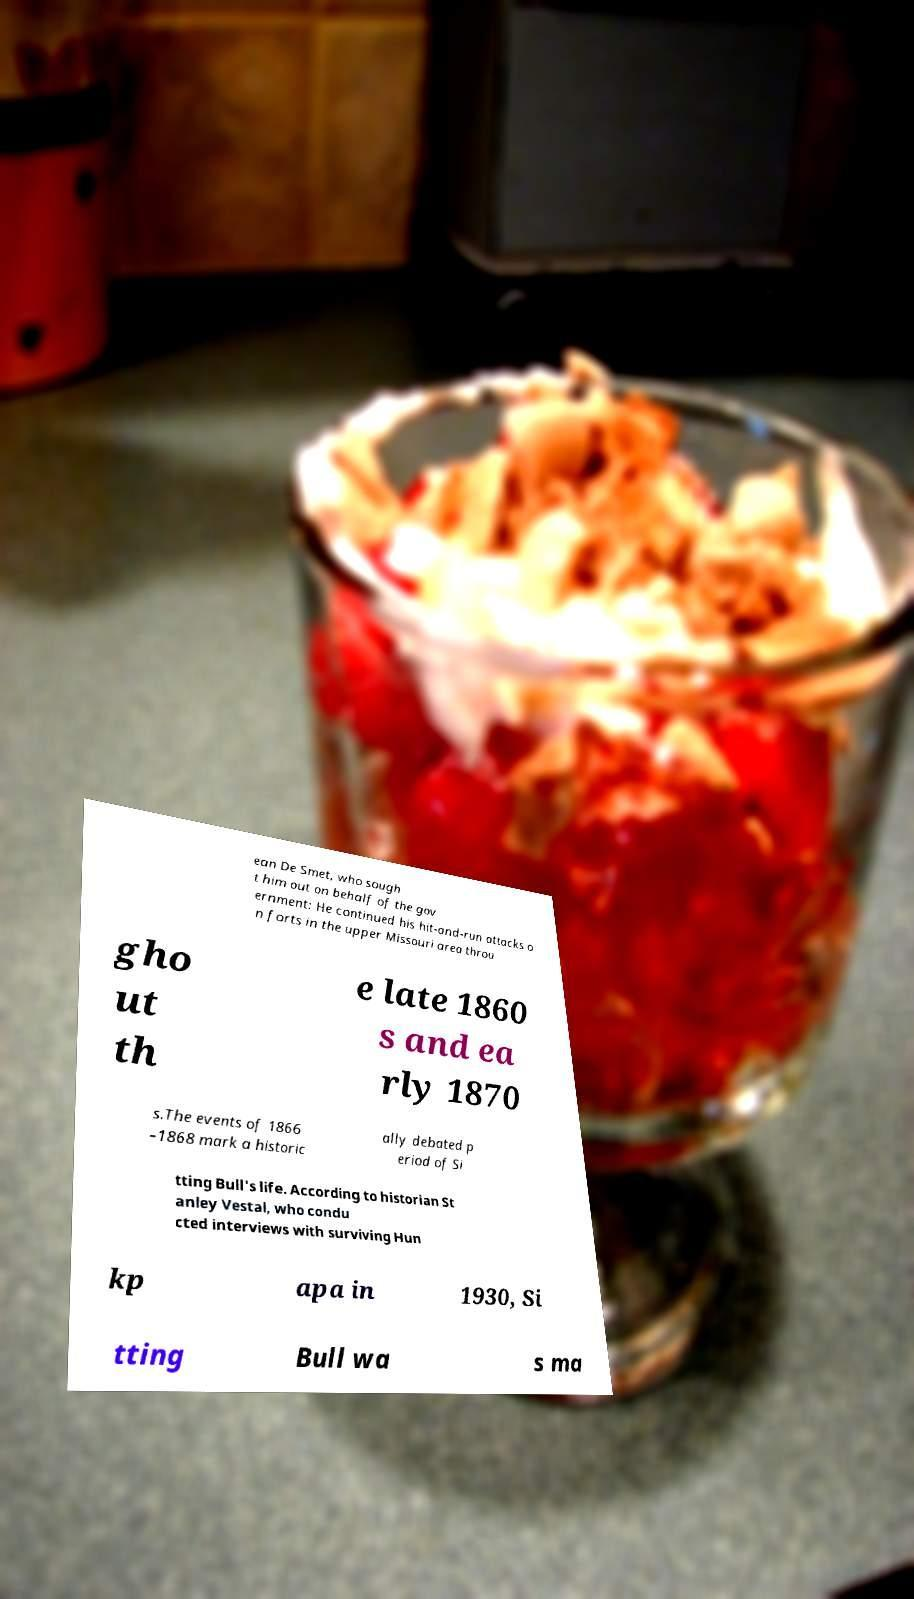What messages or text are displayed in this image? I need them in a readable, typed format. ean De Smet, who sough t him out on behalf of the gov ernment: He continued his hit-and-run attacks o n forts in the upper Missouri area throu gho ut th e late 1860 s and ea rly 1870 s.The events of 1866 –1868 mark a historic ally debated p eriod of Si tting Bull's life. According to historian St anley Vestal, who condu cted interviews with surviving Hun kp apa in 1930, Si tting Bull wa s ma 